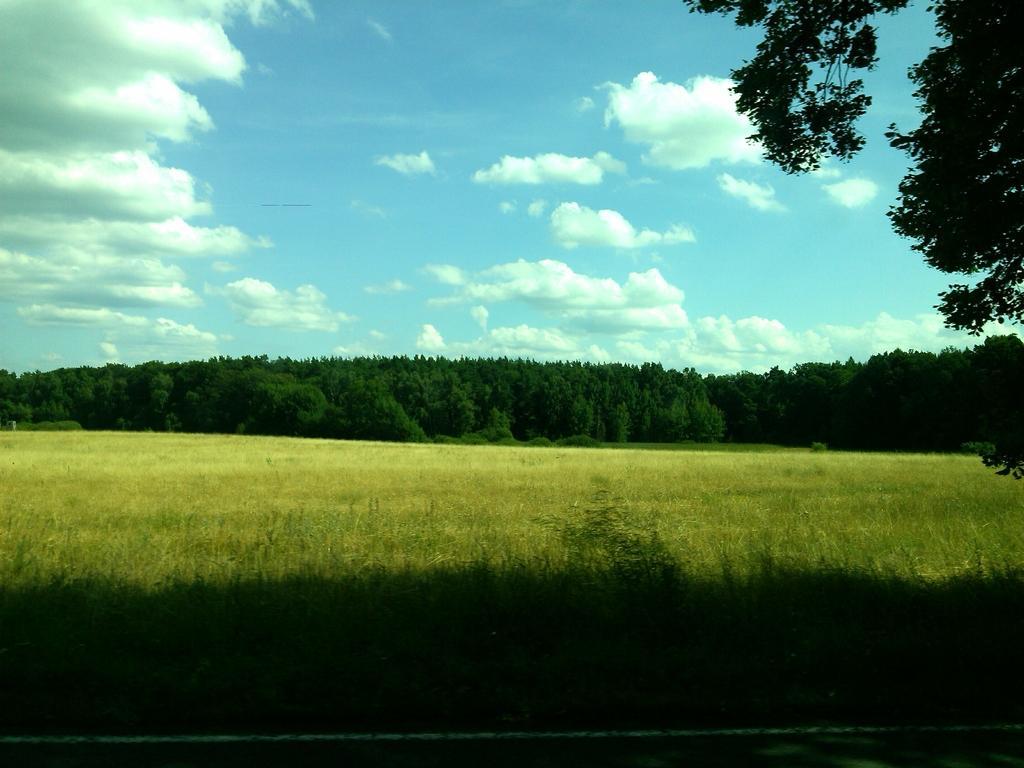Please provide a concise description of this image. In this picture we can see a land covered with green grass and trees. Here the sky is blue. 